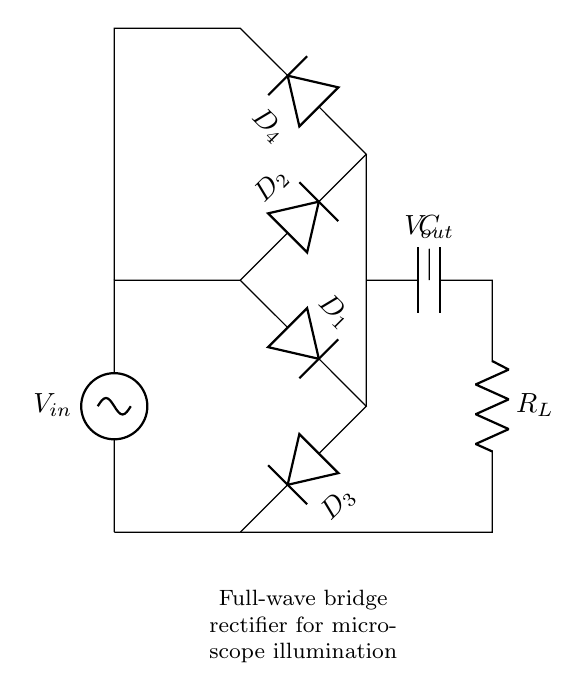What type of rectifier is shown in this circuit? The circuit diagram clearly depicts a full-wave bridge rectifier, identifiable by its configuration of four diodes arranged to allow current to pass through both halves of the input waveform.
Answer: full-wave bridge rectifier How many diodes are used in the circuit? Upon inspection of the circuit, there are four distinct diodes labeled D1, D2, D3, and D4 assembled to form the bridge rectifier.
Answer: four What is the role of the capacitor in this circuit? The capacitor (labeled C) is used in this circuit to smooth out the voltage output, reducing fluctuations and providing a more stable DC supply to the load.
Answer: smoothing Which component represents the load in the circuit? The resistor labeled R_L represents the load in this circuit, indicating where the rectified power will be utilized.
Answer: R_L What happens to the input voltage in this circuit? The input voltage is transformed from AC to DC after passing through the four diodes, resulting in a rectified output voltage suitable for powering devices.
Answer: transformed from AC to DC What is the function of diodes D1 and D3? Diodes D1 and D3 conduct during one half-cycle of the AC input, allowing current to flow through the output circuit and contributing to the full-wave rectification process.
Answer: conduct current What is the voltage output across the load? The output voltage V_out is given by the peak voltage of the AC input minus the forward voltage drop across the conducting diodes during operation.
Answer: V_out is the rectified DC voltage 